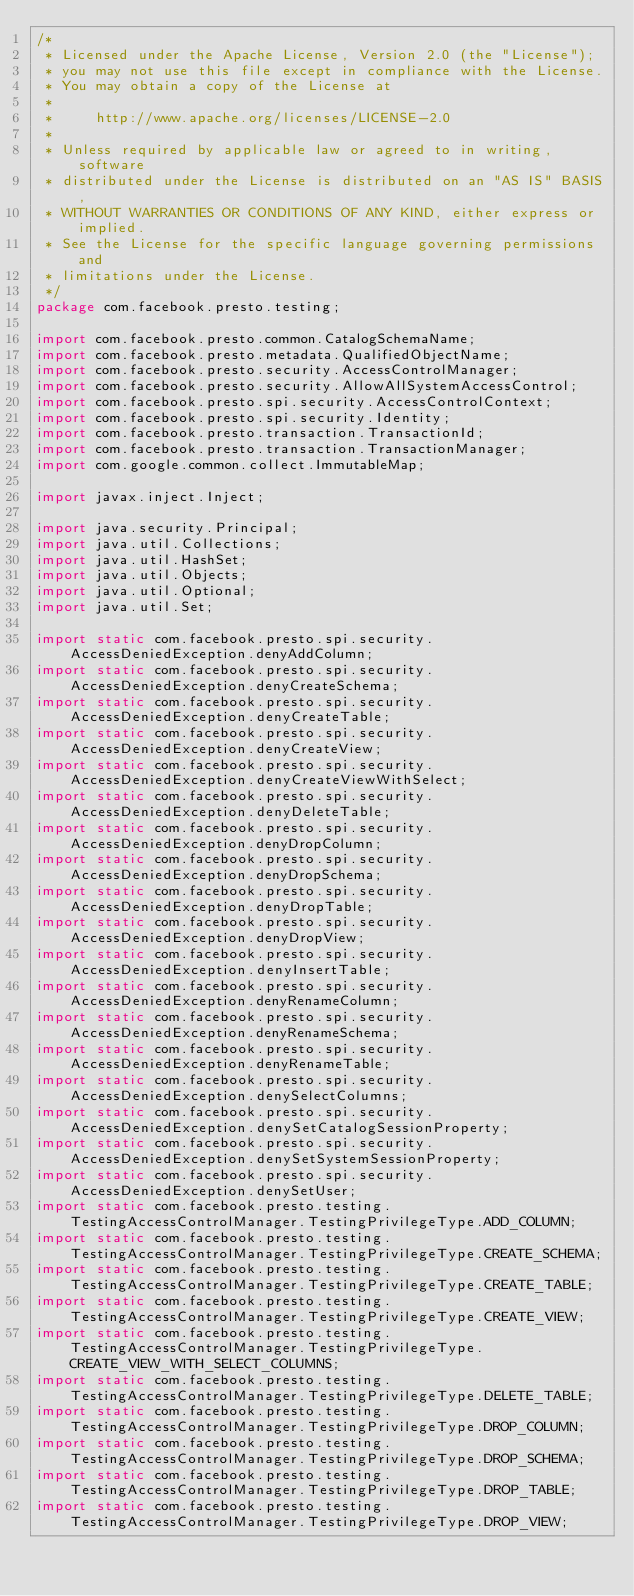<code> <loc_0><loc_0><loc_500><loc_500><_Java_>/*
 * Licensed under the Apache License, Version 2.0 (the "License");
 * you may not use this file except in compliance with the License.
 * You may obtain a copy of the License at
 *
 *     http://www.apache.org/licenses/LICENSE-2.0
 *
 * Unless required by applicable law or agreed to in writing, software
 * distributed under the License is distributed on an "AS IS" BASIS,
 * WITHOUT WARRANTIES OR CONDITIONS OF ANY KIND, either express or implied.
 * See the License for the specific language governing permissions and
 * limitations under the License.
 */
package com.facebook.presto.testing;

import com.facebook.presto.common.CatalogSchemaName;
import com.facebook.presto.metadata.QualifiedObjectName;
import com.facebook.presto.security.AccessControlManager;
import com.facebook.presto.security.AllowAllSystemAccessControl;
import com.facebook.presto.spi.security.AccessControlContext;
import com.facebook.presto.spi.security.Identity;
import com.facebook.presto.transaction.TransactionId;
import com.facebook.presto.transaction.TransactionManager;
import com.google.common.collect.ImmutableMap;

import javax.inject.Inject;

import java.security.Principal;
import java.util.Collections;
import java.util.HashSet;
import java.util.Objects;
import java.util.Optional;
import java.util.Set;

import static com.facebook.presto.spi.security.AccessDeniedException.denyAddColumn;
import static com.facebook.presto.spi.security.AccessDeniedException.denyCreateSchema;
import static com.facebook.presto.spi.security.AccessDeniedException.denyCreateTable;
import static com.facebook.presto.spi.security.AccessDeniedException.denyCreateView;
import static com.facebook.presto.spi.security.AccessDeniedException.denyCreateViewWithSelect;
import static com.facebook.presto.spi.security.AccessDeniedException.denyDeleteTable;
import static com.facebook.presto.spi.security.AccessDeniedException.denyDropColumn;
import static com.facebook.presto.spi.security.AccessDeniedException.denyDropSchema;
import static com.facebook.presto.spi.security.AccessDeniedException.denyDropTable;
import static com.facebook.presto.spi.security.AccessDeniedException.denyDropView;
import static com.facebook.presto.spi.security.AccessDeniedException.denyInsertTable;
import static com.facebook.presto.spi.security.AccessDeniedException.denyRenameColumn;
import static com.facebook.presto.spi.security.AccessDeniedException.denyRenameSchema;
import static com.facebook.presto.spi.security.AccessDeniedException.denyRenameTable;
import static com.facebook.presto.spi.security.AccessDeniedException.denySelectColumns;
import static com.facebook.presto.spi.security.AccessDeniedException.denySetCatalogSessionProperty;
import static com.facebook.presto.spi.security.AccessDeniedException.denySetSystemSessionProperty;
import static com.facebook.presto.spi.security.AccessDeniedException.denySetUser;
import static com.facebook.presto.testing.TestingAccessControlManager.TestingPrivilegeType.ADD_COLUMN;
import static com.facebook.presto.testing.TestingAccessControlManager.TestingPrivilegeType.CREATE_SCHEMA;
import static com.facebook.presto.testing.TestingAccessControlManager.TestingPrivilegeType.CREATE_TABLE;
import static com.facebook.presto.testing.TestingAccessControlManager.TestingPrivilegeType.CREATE_VIEW;
import static com.facebook.presto.testing.TestingAccessControlManager.TestingPrivilegeType.CREATE_VIEW_WITH_SELECT_COLUMNS;
import static com.facebook.presto.testing.TestingAccessControlManager.TestingPrivilegeType.DELETE_TABLE;
import static com.facebook.presto.testing.TestingAccessControlManager.TestingPrivilegeType.DROP_COLUMN;
import static com.facebook.presto.testing.TestingAccessControlManager.TestingPrivilegeType.DROP_SCHEMA;
import static com.facebook.presto.testing.TestingAccessControlManager.TestingPrivilegeType.DROP_TABLE;
import static com.facebook.presto.testing.TestingAccessControlManager.TestingPrivilegeType.DROP_VIEW;</code> 